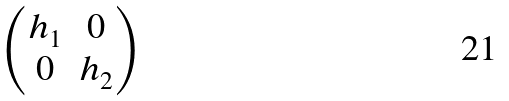Convert formula to latex. <formula><loc_0><loc_0><loc_500><loc_500>\begin{pmatrix} h _ { 1 } & 0 \\ 0 & h _ { 2 } \end{pmatrix}</formula> 